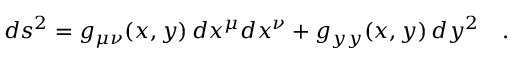Convert formula to latex. <formula><loc_0><loc_0><loc_500><loc_500>d s ^ { 2 } = g _ { \mu \nu } ( x , y ) \, d x ^ { \mu } d x ^ { \nu } + g _ { y y } ( x , y ) \, d y ^ { 2 } \quad .</formula> 